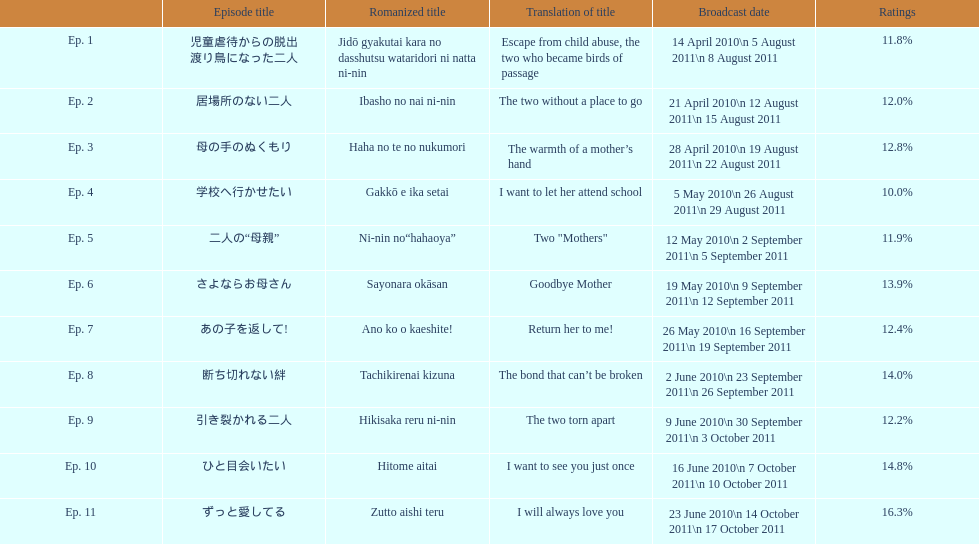What were the episode names of mother? 児童虐待からの脱出 渡り鳥になった二人, 居場所のない二人, 母の手のぬくもり, 学校へ行かせたい, 二人の“母親”, さよならお母さん, あの子を返して!, 断ち切れない絆, 引き裂かれる二人, ひと目会いたい, ずっと愛してる. Which of these episodes achieved the highest rankings? ずっと愛してる. 